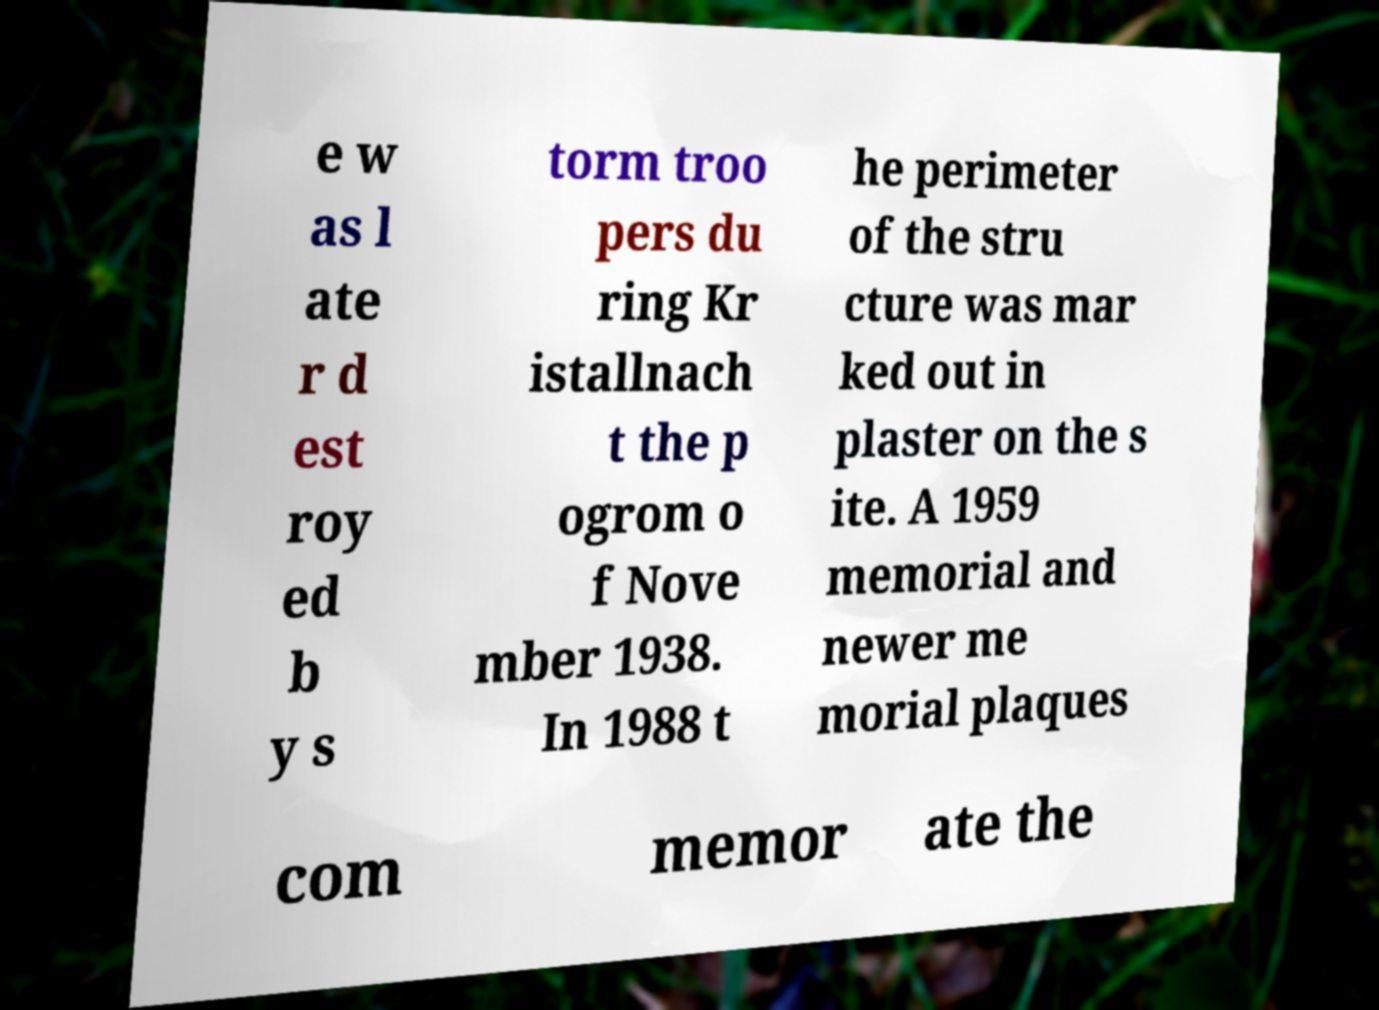There's text embedded in this image that I need extracted. Can you transcribe it verbatim? e w as l ate r d est roy ed b y s torm troo pers du ring Kr istallnach t the p ogrom o f Nove mber 1938. In 1988 t he perimeter of the stru cture was mar ked out in plaster on the s ite. A 1959 memorial and newer me morial plaques com memor ate the 